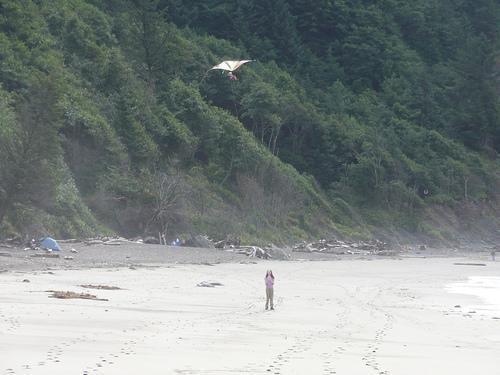What flutters just beneath the main body of this kite?
Choose the correct response, then elucidate: 'Answer: answer
Rationale: rationale.'
Options: Nothing, eagle, tail, pigeon. Answer: tail.
Rationale: There is something just beneath the kite's main body. there are no birds near the kite. 